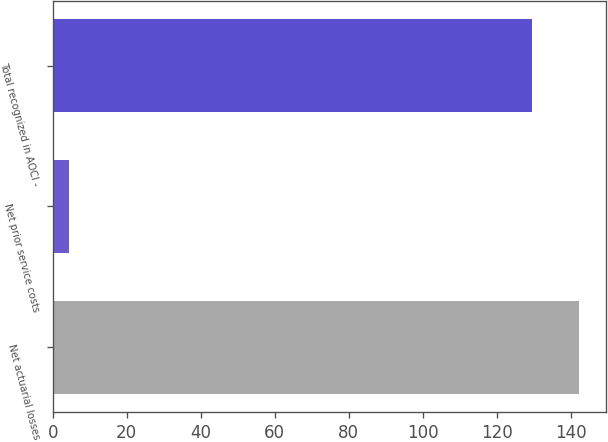Convert chart to OTSL. <chart><loc_0><loc_0><loc_500><loc_500><bar_chart><fcel>Net actuarial losses<fcel>Net prior service costs<fcel>Total recognized in AOCI -<nl><fcel>142.34<fcel>4.5<fcel>129.4<nl></chart> 